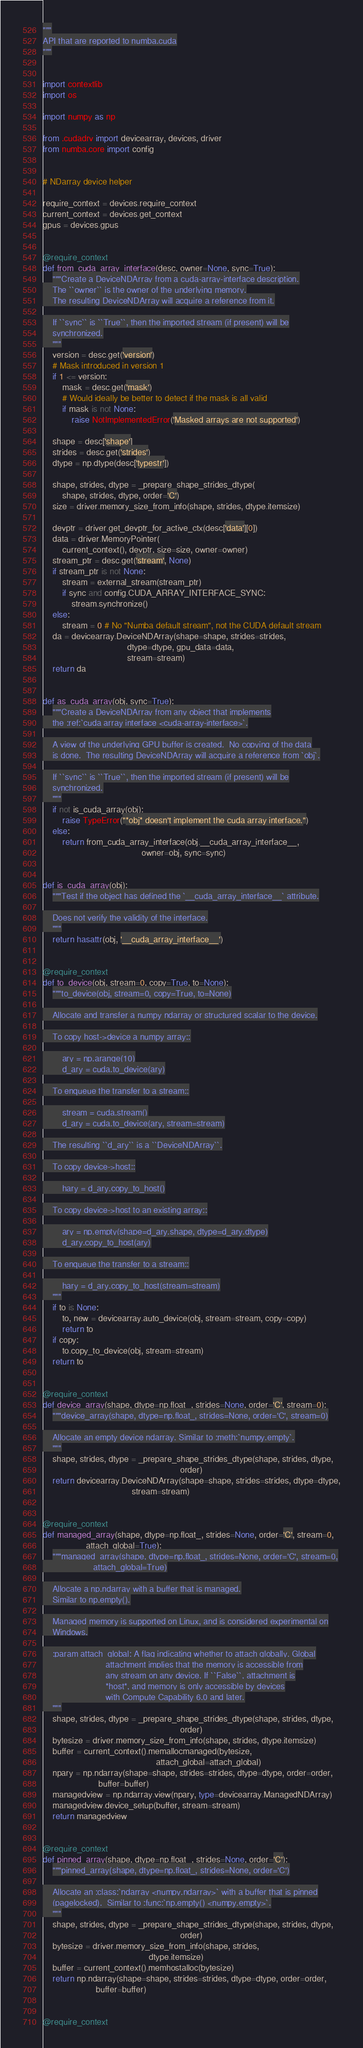Convert code to text. <code><loc_0><loc_0><loc_500><loc_500><_Python_>"""
API that are reported to numba.cuda
"""


import contextlib
import os

import numpy as np

from .cudadrv import devicearray, devices, driver
from numba.core import config


# NDarray device helper

require_context = devices.require_context
current_context = devices.get_context
gpus = devices.gpus


@require_context
def from_cuda_array_interface(desc, owner=None, sync=True):
    """Create a DeviceNDArray from a cuda-array-interface description.
    The ``owner`` is the owner of the underlying memory.
    The resulting DeviceNDArray will acquire a reference from it.

    If ``sync`` is ``True``, then the imported stream (if present) will be
    synchronized.
    """
    version = desc.get('version')
    # Mask introduced in version 1
    if 1 <= version:
        mask = desc.get('mask')
        # Would ideally be better to detect if the mask is all valid
        if mask is not None:
            raise NotImplementedError('Masked arrays are not supported')

    shape = desc['shape']
    strides = desc.get('strides')
    dtype = np.dtype(desc['typestr'])

    shape, strides, dtype = _prepare_shape_strides_dtype(
        shape, strides, dtype, order='C')
    size = driver.memory_size_from_info(shape, strides, dtype.itemsize)

    devptr = driver.get_devptr_for_active_ctx(desc['data'][0])
    data = driver.MemoryPointer(
        current_context(), devptr, size=size, owner=owner)
    stream_ptr = desc.get('stream', None)
    if stream_ptr is not None:
        stream = external_stream(stream_ptr)
        if sync and config.CUDA_ARRAY_INTERFACE_SYNC:
            stream.synchronize()
    else:
        stream = 0 # No "Numba default stream", not the CUDA default stream
    da = devicearray.DeviceNDArray(shape=shape, strides=strides,
                                   dtype=dtype, gpu_data=data,
                                   stream=stream)
    return da


def as_cuda_array(obj, sync=True):
    """Create a DeviceNDArray from any object that implements
    the :ref:`cuda array interface <cuda-array-interface>`.

    A view of the underlying GPU buffer is created.  No copying of the data
    is done.  The resulting DeviceNDArray will acquire a reference from `obj`.

    If ``sync`` is ``True``, then the imported stream (if present) will be
    synchronized.
    """
    if not is_cuda_array(obj):
        raise TypeError("*obj* doesn't implement the cuda array interface.")
    else:
        return from_cuda_array_interface(obj.__cuda_array_interface__,
                                         owner=obj, sync=sync)


def is_cuda_array(obj):
    """Test if the object has defined the `__cuda_array_interface__` attribute.

    Does not verify the validity of the interface.
    """
    return hasattr(obj, '__cuda_array_interface__')


@require_context
def to_device(obj, stream=0, copy=True, to=None):
    """to_device(obj, stream=0, copy=True, to=None)

    Allocate and transfer a numpy ndarray or structured scalar to the device.

    To copy host->device a numpy array::

        ary = np.arange(10)
        d_ary = cuda.to_device(ary)

    To enqueue the transfer to a stream::

        stream = cuda.stream()
        d_ary = cuda.to_device(ary, stream=stream)

    The resulting ``d_ary`` is a ``DeviceNDArray``.

    To copy device->host::

        hary = d_ary.copy_to_host()

    To copy device->host to an existing array::

        ary = np.empty(shape=d_ary.shape, dtype=d_ary.dtype)
        d_ary.copy_to_host(ary)

    To enqueue the transfer to a stream::

        hary = d_ary.copy_to_host(stream=stream)
    """
    if to is None:
        to, new = devicearray.auto_device(obj, stream=stream, copy=copy)
        return to
    if copy:
        to.copy_to_device(obj, stream=stream)
    return to


@require_context
def device_array(shape, dtype=np.float_, strides=None, order='C', stream=0):
    """device_array(shape, dtype=np.float_, strides=None, order='C', stream=0)

    Allocate an empty device ndarray. Similar to :meth:`numpy.empty`.
    """
    shape, strides, dtype = _prepare_shape_strides_dtype(shape, strides, dtype,
                                                         order)
    return devicearray.DeviceNDArray(shape=shape, strides=strides, dtype=dtype,
                                     stream=stream)


@require_context
def managed_array(shape, dtype=np.float_, strides=None, order='C', stream=0,
                  attach_global=True):
    """managed_array(shape, dtype=np.float_, strides=None, order='C', stream=0,
                     attach_global=True)

    Allocate a np.ndarray with a buffer that is managed.
    Similar to np.empty().

    Managed memory is supported on Linux, and is considered experimental on
    Windows.

    :param attach_global: A flag indicating whether to attach globally. Global
                          attachment implies that the memory is accessible from
                          any stream on any device. If ``False``, attachment is
                          *host*, and memory is only accessible by devices
                          with Compute Capability 6.0 and later.
    """
    shape, strides, dtype = _prepare_shape_strides_dtype(shape, strides, dtype,
                                                         order)
    bytesize = driver.memory_size_from_info(shape, strides, dtype.itemsize)
    buffer = current_context().memallocmanaged(bytesize,
                                               attach_global=attach_global)
    npary = np.ndarray(shape=shape, strides=strides, dtype=dtype, order=order,
                       buffer=buffer)
    managedview = np.ndarray.view(npary, type=devicearray.ManagedNDArray)
    managedview.device_setup(buffer, stream=stream)
    return managedview


@require_context
def pinned_array(shape, dtype=np.float_, strides=None, order='C'):
    """pinned_array(shape, dtype=np.float_, strides=None, order='C')

    Allocate an :class:`ndarray <numpy.ndarray>` with a buffer that is pinned
    (pagelocked).  Similar to :func:`np.empty() <numpy.empty>`.
    """
    shape, strides, dtype = _prepare_shape_strides_dtype(shape, strides, dtype,
                                                         order)
    bytesize = driver.memory_size_from_info(shape, strides,
                                            dtype.itemsize)
    buffer = current_context().memhostalloc(bytesize)
    return np.ndarray(shape=shape, strides=strides, dtype=dtype, order=order,
                      buffer=buffer)


@require_context</code> 